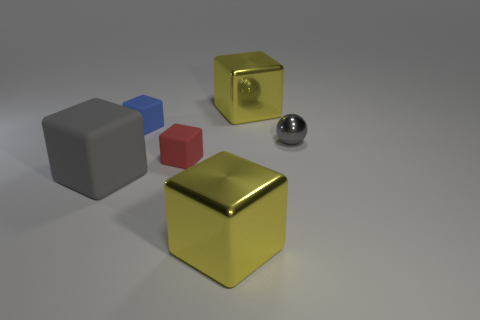Subtract 2 cubes. How many cubes are left? 3 Subtract all red cubes. How many cubes are left? 4 Subtract all tiny blue matte blocks. How many blocks are left? 4 Subtract all blue blocks. Subtract all brown cylinders. How many blocks are left? 4 Add 3 big yellow matte cylinders. How many objects exist? 9 Subtract all balls. How many objects are left? 5 Add 1 large purple rubber objects. How many large purple rubber objects exist? 1 Subtract 0 green blocks. How many objects are left? 6 Subtract all yellow metallic spheres. Subtract all cubes. How many objects are left? 1 Add 4 rubber blocks. How many rubber blocks are left? 7 